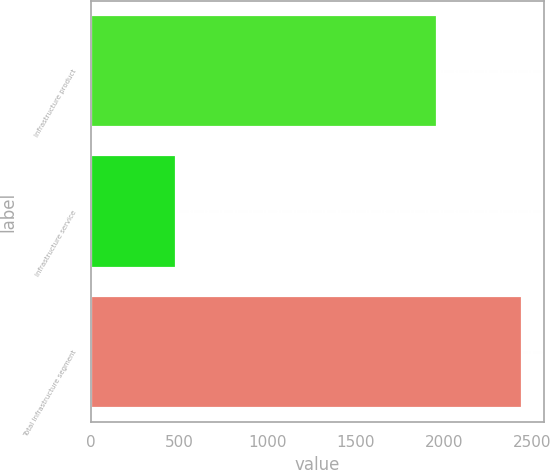<chart> <loc_0><loc_0><loc_500><loc_500><bar_chart><fcel>Infrastructure product<fcel>Infrastructure service<fcel>Total Infrastructure segment<nl><fcel>1959.2<fcel>482.4<fcel>2441.6<nl></chart> 